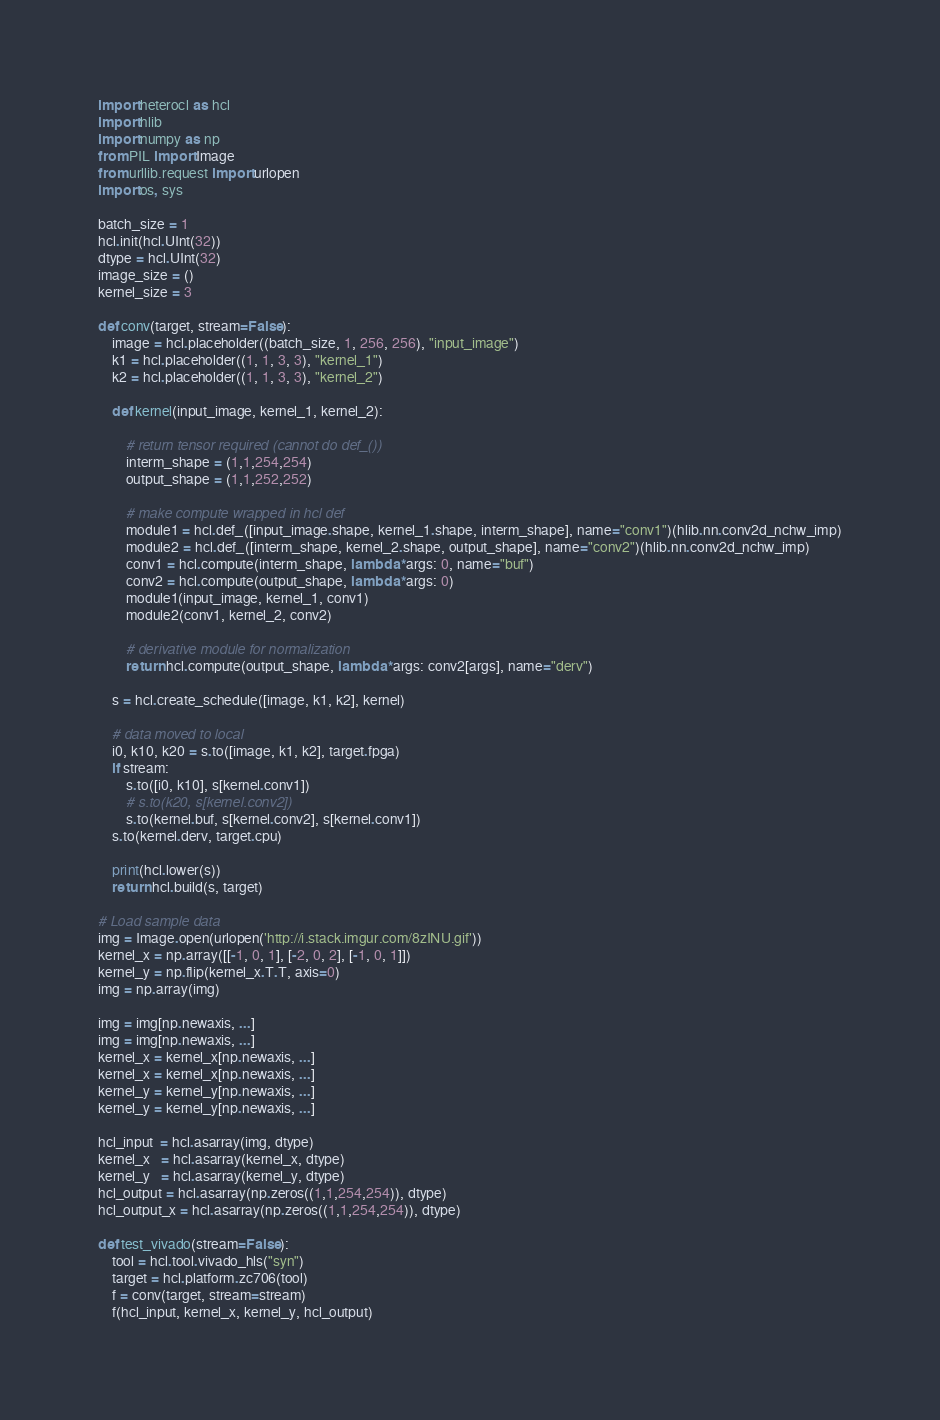<code> <loc_0><loc_0><loc_500><loc_500><_Python_>import heterocl as hcl
import hlib
import numpy as np
from PIL import Image
from urllib.request import urlopen
import os, sys

batch_size = 1
hcl.init(hcl.UInt(32))
dtype = hcl.UInt(32)
image_size = ()
kernel_size = 3

def conv(target, stream=False):
    image = hcl.placeholder((batch_size, 1, 256, 256), "input_image")
    k1 = hcl.placeholder((1, 1, 3, 3), "kernel_1")
    k2 = hcl.placeholder((1, 1, 3, 3), "kernel_2")

    def kernel(input_image, kernel_1, kernel_2):

        # return tensor required (cannot do def_())
        interm_shape = (1,1,254,254)
        output_shape = (1,1,252,252)

        # make compute wrapped in hcl def
        module1 = hcl.def_([input_image.shape, kernel_1.shape, interm_shape], name="conv1")(hlib.nn.conv2d_nchw_imp)
        module2 = hcl.def_([interm_shape, kernel_2.shape, output_shape], name="conv2")(hlib.nn.conv2d_nchw_imp)
        conv1 = hcl.compute(interm_shape, lambda *args: 0, name="buf")  
        conv2 = hcl.compute(output_shape, lambda *args: 0)  
        module1(input_image, kernel_1, conv1)
        module2(conv1, kernel_2, conv2)

        # derivative module for normalization 
        return hcl.compute(output_shape, lambda *args: conv2[args], name="derv")

    s = hcl.create_schedule([image, k1, k2], kernel)

    # data moved to local  
    i0, k10, k20 = s.to([image, k1, k2], target.fpga)
    if stream:
        s.to([i0, k10], s[kernel.conv1])
        # s.to(k20, s[kernel.conv2])
        s.to(kernel.buf, s[kernel.conv2], s[kernel.conv1])
    s.to(kernel.derv, target.cpu)

    print(hcl.lower(s))
    return hcl.build(s, target)

# Load sample data
img = Image.open(urlopen('http://i.stack.imgur.com/8zINU.gif'))
kernel_x = np.array([[-1, 0, 1], [-2, 0, 2], [-1, 0, 1]])
kernel_y = np.flip(kernel_x.T.T, axis=0)
img = np.array(img)

img = img[np.newaxis, ...]
img = img[np.newaxis, ...]
kernel_x = kernel_x[np.newaxis, ...]
kernel_x = kernel_x[np.newaxis, ...]
kernel_y = kernel_y[np.newaxis, ...]
kernel_y = kernel_y[np.newaxis, ...]

hcl_input  = hcl.asarray(img, dtype)    
kernel_x   = hcl.asarray(kernel_x, dtype)
kernel_y   = hcl.asarray(kernel_y, dtype)
hcl_output = hcl.asarray(np.zeros((1,1,254,254)), dtype)    
hcl_output_x = hcl.asarray(np.zeros((1,1,254,254)), dtype)    

def test_vivado(stream=False):
    tool = hcl.tool.vivado_hls("syn")
    target = hcl.platform.zc706(tool)
    f = conv(target, stream=stream)
    f(hcl_input, kernel_x, kernel_y, hcl_output)</code> 